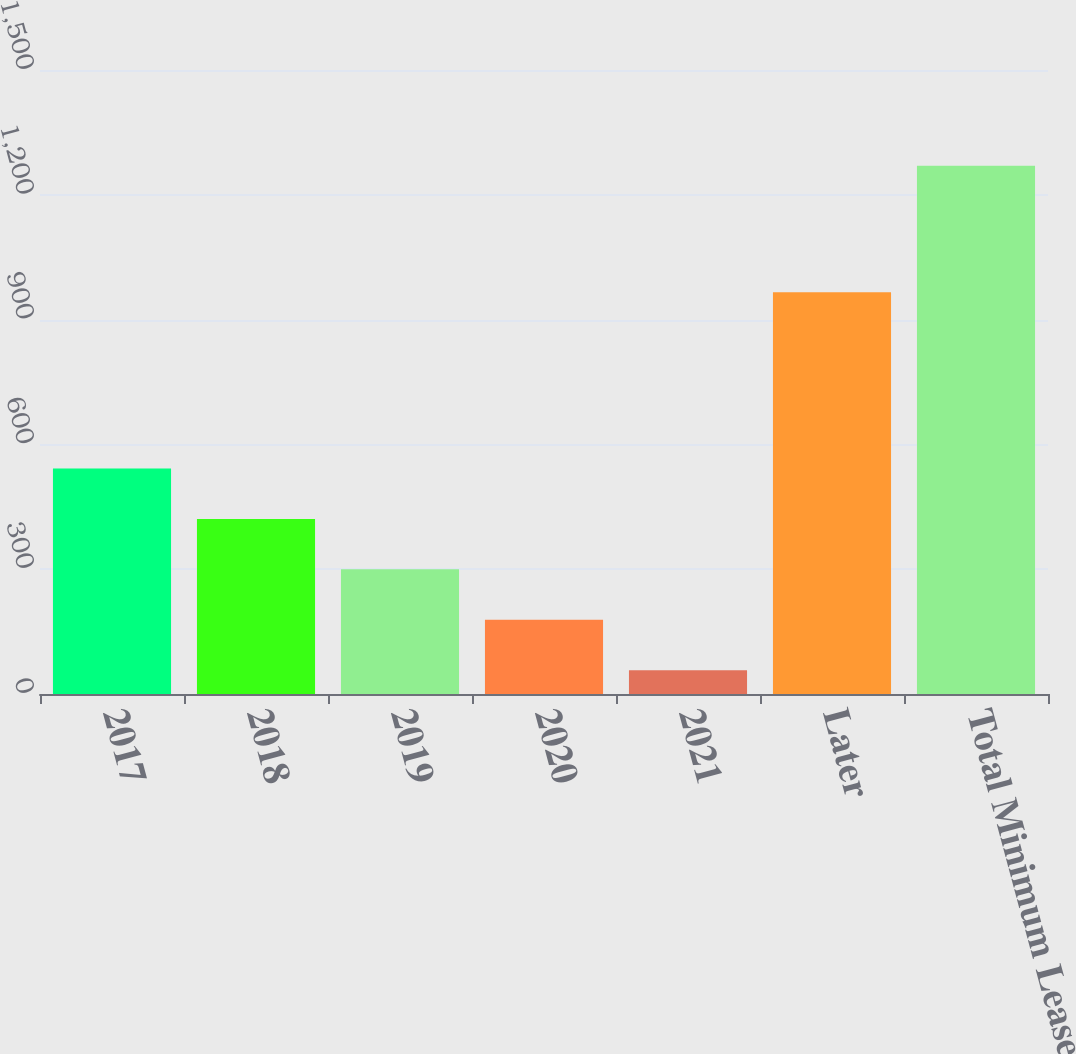Convert chart. <chart><loc_0><loc_0><loc_500><loc_500><bar_chart><fcel>2017<fcel>2018<fcel>2019<fcel>2020<fcel>2021<fcel>Later<fcel>Total Minimum Lease Payments<nl><fcel>542.2<fcel>420.9<fcel>299.6<fcel>178.3<fcel>57<fcel>966<fcel>1270<nl></chart> 